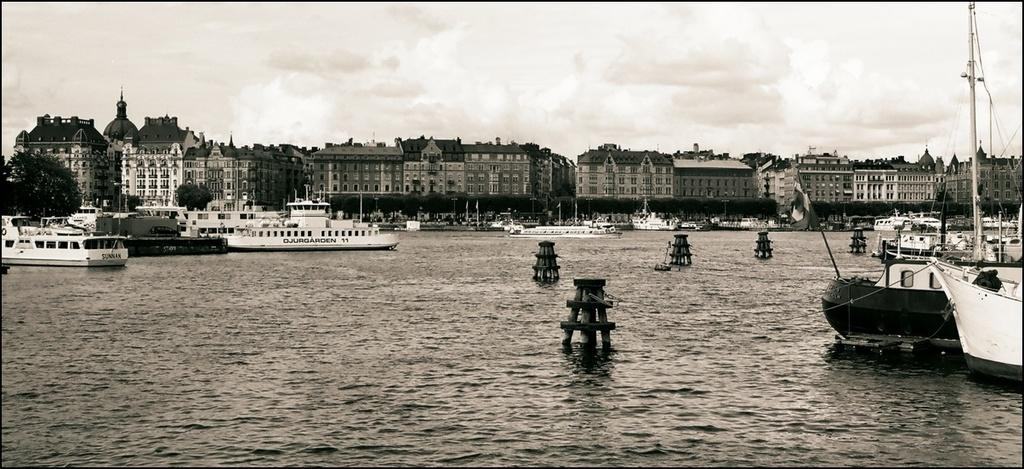What is the color scheme of the image? The image is black and white. What type of structures can be seen in the image? There are buildings in the image. What other objects are present in the image? There are boats and trees visible in the image. What is visible at the top of the image? The sky is visible at the top of the image, and clouds are present in the sky. What is visible at the bottom of the image? There is water visible at the bottom of the image. Where is the stone used for skipping in the image? There is no stone present in the image for skipping. What type of kite can be seen flying in the image? There is no kite present in the image. 